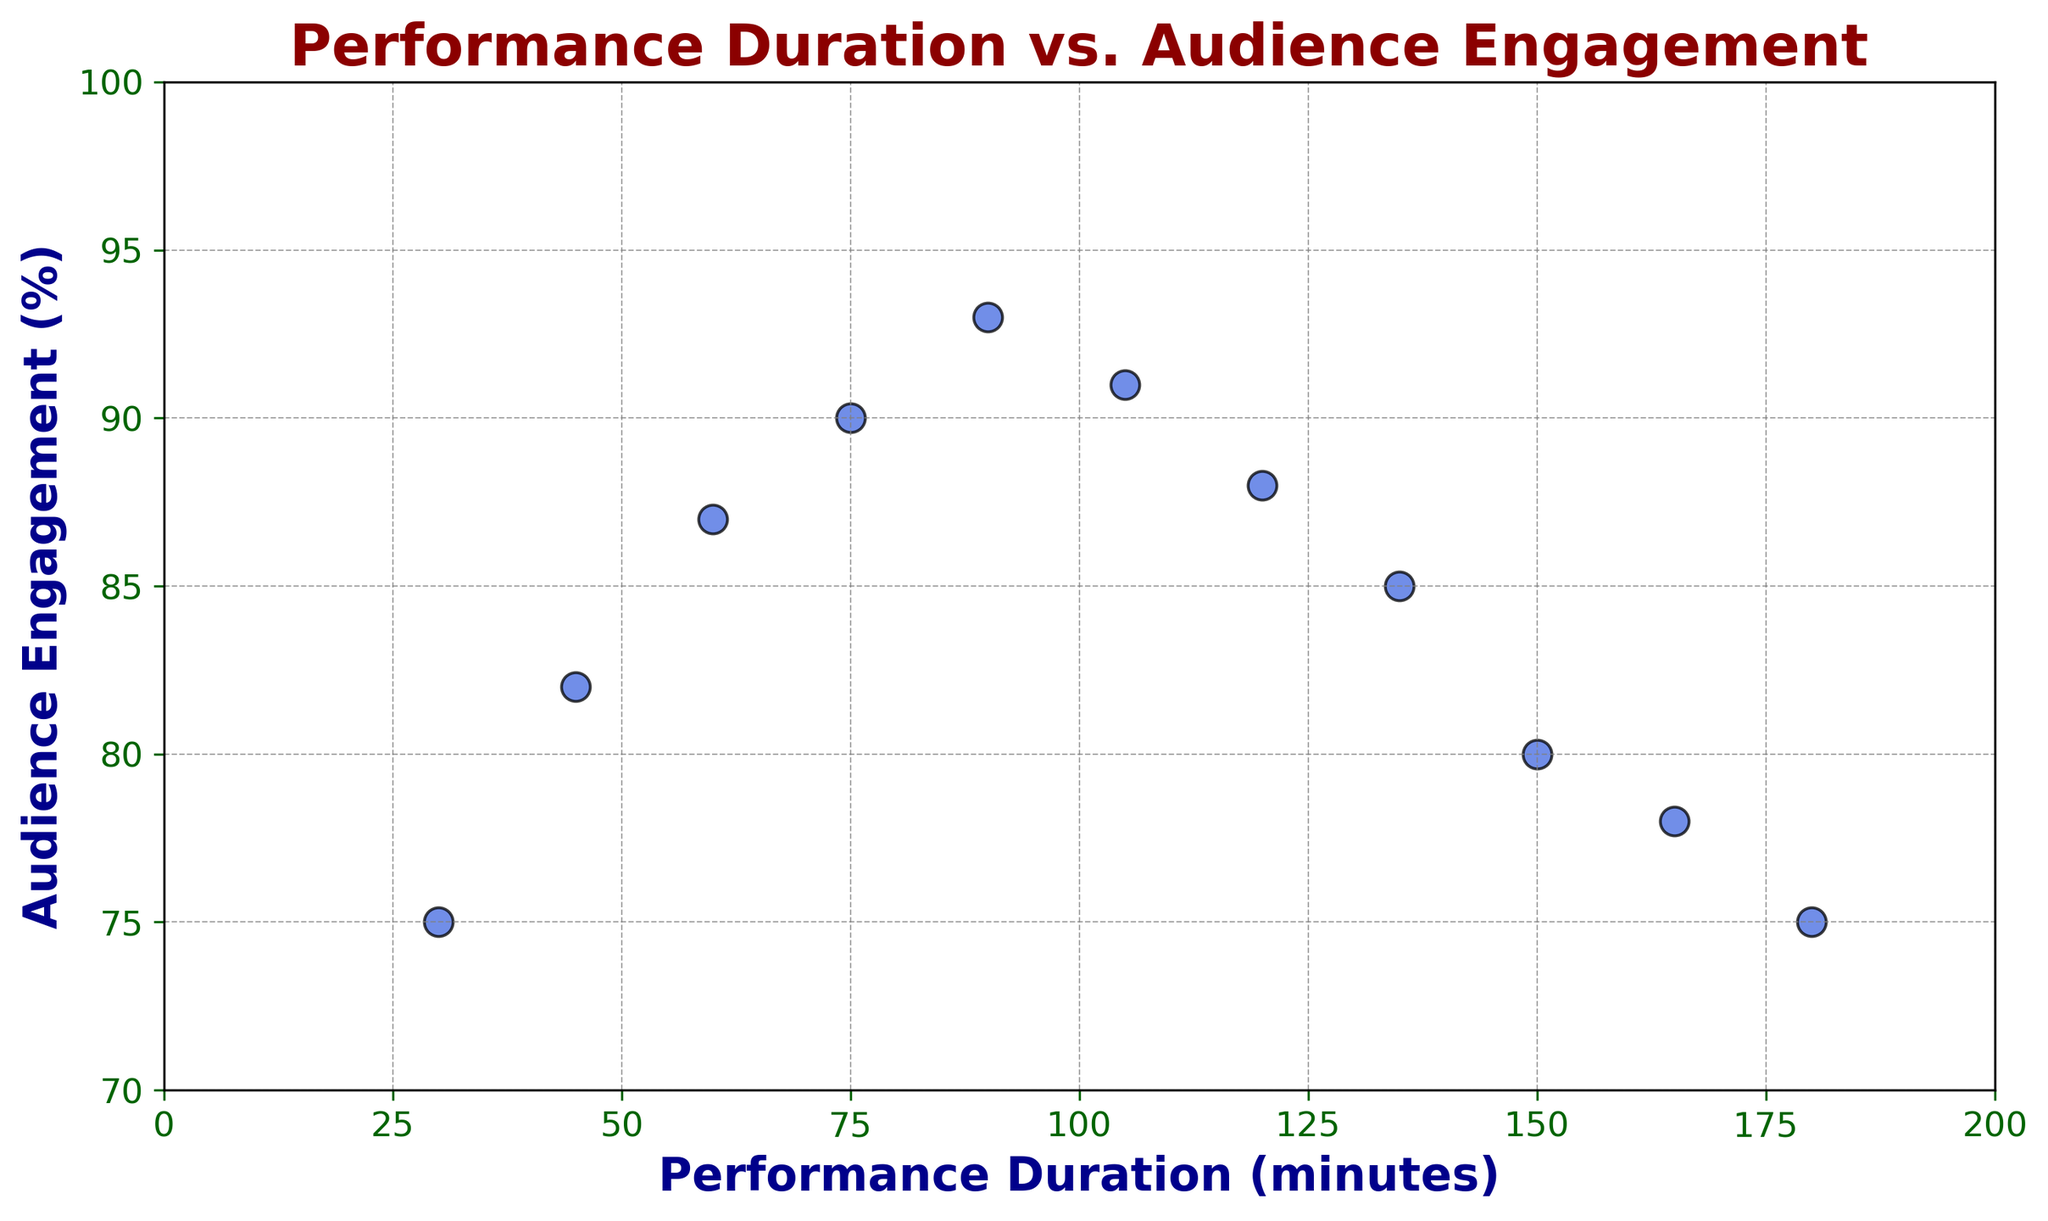What is the highest value of Audience Engagement shown in the plot? Look at the y-axis and find the highest point reached by any data point. The highest value on the y-axis is 93.
Answer: 93 What is the Performance Duration for the highest Audience Engagement? Find the data point corresponding to the highest value of Audience Engagement (93). The x-axis value for this point is 90 minutes.
Answer: 90 minutes What is the average Audience Engagement for performances with a duration less than 90 minutes? Identify points where Performance duration is less than 90 minutes (30, 45, 60, 75 minutes). Audience Engagement values for these points are 75, 82, 87, and 90. Calculate the average: (75+82+87+90)/4 = 83.5.
Answer: 83.5 Is there a Performance Duration after which Audience Engagement starts to decrease? Observe the scatter plot. Note that Audience Engagement peaks at 90 minutes. After 90 minutes, Audience Engagement generally declines.
Answer: Yes What is the difference in Audience Engagement between the shortest and the longest performance durations? Find the Audience Engagement for the shortest (30 minutes, 75%) and longest (180 minutes, 75%) durations. Calculate the difference: 75 - 75 = 0.
Answer: 0 How does Audience Engagement change between 75 and 105 minutes of Performance Duration? Examine data points for Performance Durations 75, 90, and 105 minutes. Corresponding Audience Engagement values are: 90, 93, and 91. Note that Engagement increases from 75 to 90 minutes and slightly decreases from 90 to 105 minutes.
Answer: Initially increases, then slightly decreases Which Performance Duration has the lowest Audience Engagement above 100 minutes? Look for data points with Performance Duration > 100 minutes. Durations are 105, 120, 135, 150, 165, and 180 minutes. Corresponding Engagement values are 91, 88, 85, 80, 78, and 75. The lowest value is 75 at 180 minutes.
Answer: 180 minutes Does the plot indicate any visual pattern between Performance Duration and Audience Engagement? Look at the general trend in the scatter plot. Audience Engagement increases with Performance Duration up to around 90 minutes and then starts to decrease.
Answer: Yes, initial increase then decrease What is the difference in Audience Engagement between 60 and 120 minutes of Performance Duration? Identify points for 60 minutes (87%) and 120 minutes (88%) of Performance Duration. Calculate the difference: 88 - 87 = 1.
Answer: 1 What is the median Audience Engagement for all performances? List all Audience Engagement values: 75, 78, 80, 82, 85, 87, 88, 90, 91, 93. The median is the middle value in this ordered list. Since there are 11 values, the median is the 6th value, which is 87.
Answer: 87 